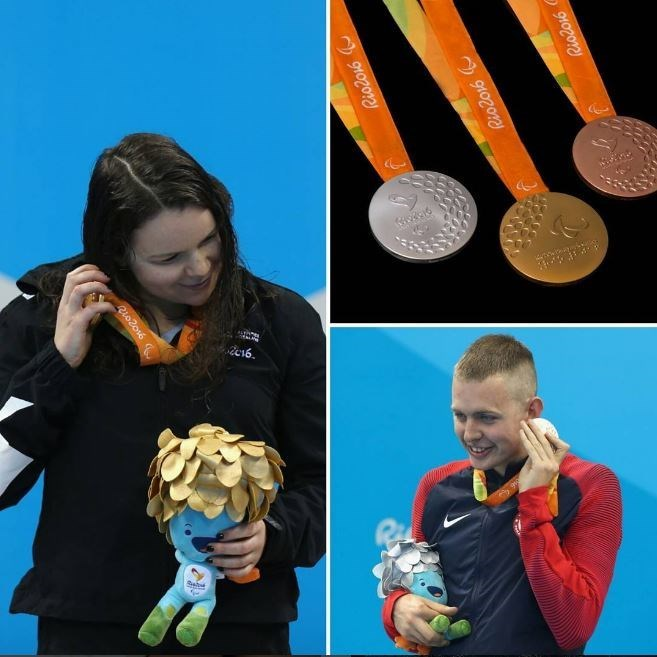Can you write a creative story about the journey of one of the athletes to the Olympics? Once upon a time, in a small coastal village, lived a young swimmer named Talia. From an early age, she found solace in the waves and spent hours perfecting her stroke, inspired by the stories of Olympic greats. Talia's dedication saw her rise through regional competitions, each victory fueled by her dream of reaching the Olympics. Overcoming challenges and pushing through grueling training sessions, she caught the eye of national coaches and was eventually selected to represent her country at the Rio 2016 Olympics. The journey was intense - filled with moments of doubt and triumph, but Talia's spirit remained unbroken. Standing on the Olympic podium, she held her silver medal with pride, knowing it was the symbol of every ounce of effort she had poured into her dream. Her journey was a testament to perseverance, illustrating that no dream is too distant for those who dare to pursue it. 